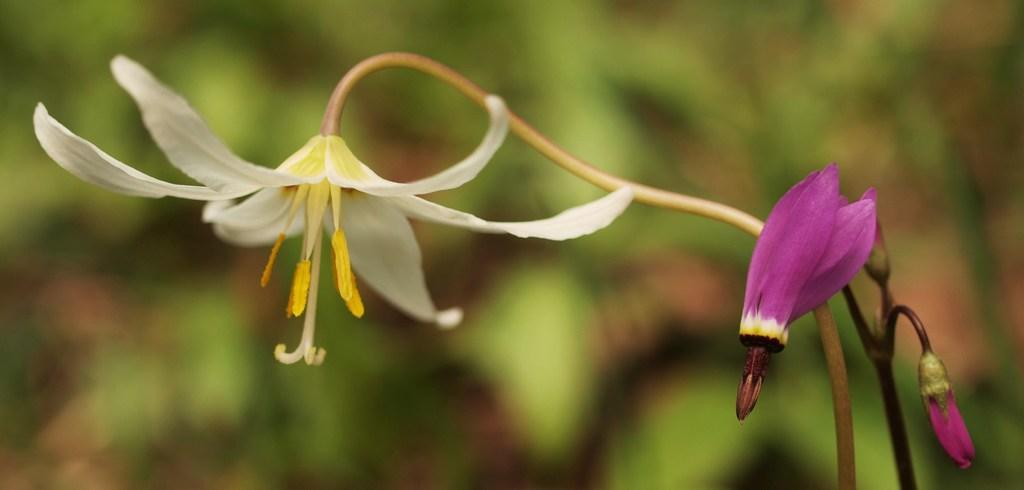What is present in the image? There are flowers in the image. Can you describe the background of the image? The background of the image is blurry. Are there any porters carrying goods in the image? There is no mention of porters or goods in the image; it only features flowers and a blurry background. 